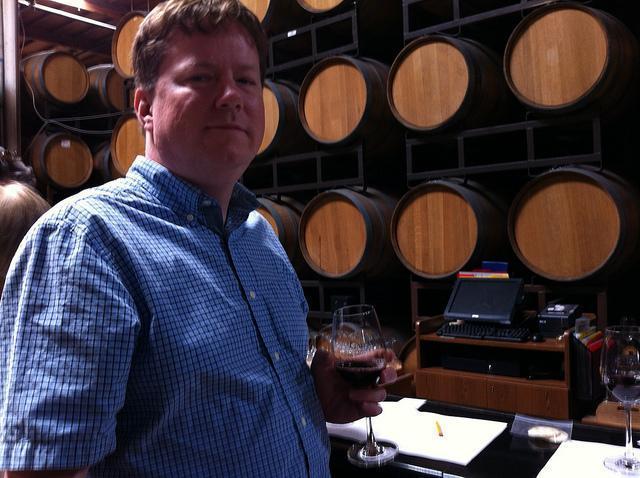How many wine glasses are there?
Give a very brief answer. 2. 